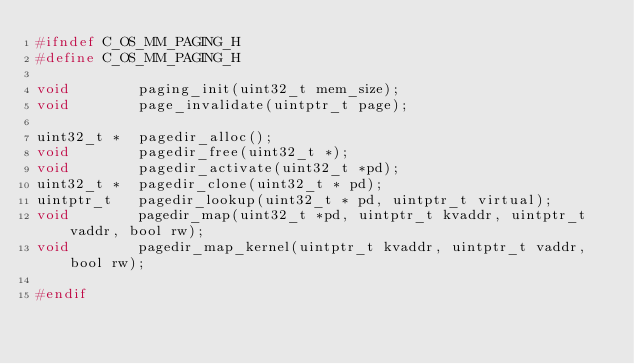Convert code to text. <code><loc_0><loc_0><loc_500><loc_500><_C_>#ifndef C_OS_MM_PAGING_H
#define C_OS_MM_PAGING_H

void		paging_init(uint32_t mem_size);
void		page_invalidate(uintptr_t page);

uint32_t *	pagedir_alloc();
void		pagedir_free(uint32_t *);
void		pagedir_activate(uint32_t *pd);
uint32_t *	pagedir_clone(uint32_t * pd);
uintptr_t	pagedir_lookup(uint32_t * pd, uintptr_t virtual);
void		pagedir_map(uint32_t *pd, uintptr_t kvaddr, uintptr_t vaddr, bool rw);
void		pagedir_map_kernel(uintptr_t kvaddr, uintptr_t vaddr, bool rw);

#endif
</code> 